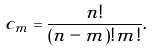<formula> <loc_0><loc_0><loc_500><loc_500>c _ { m } = \frac { n ! } { ( n - m ) ! m ! } .</formula> 